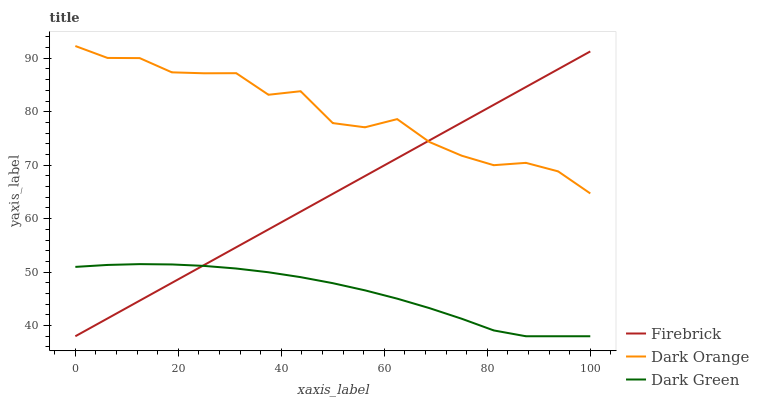Does Dark Green have the minimum area under the curve?
Answer yes or no. Yes. Does Dark Orange have the maximum area under the curve?
Answer yes or no. Yes. Does Firebrick have the minimum area under the curve?
Answer yes or no. No. Does Firebrick have the maximum area under the curve?
Answer yes or no. No. Is Firebrick the smoothest?
Answer yes or no. Yes. Is Dark Orange the roughest?
Answer yes or no. Yes. Is Dark Green the smoothest?
Answer yes or no. No. Is Dark Green the roughest?
Answer yes or no. No. Does Firebrick have the lowest value?
Answer yes or no. Yes. Does Dark Orange have the highest value?
Answer yes or no. Yes. Does Firebrick have the highest value?
Answer yes or no. No. Is Dark Green less than Dark Orange?
Answer yes or no. Yes. Is Dark Orange greater than Dark Green?
Answer yes or no. Yes. Does Dark Orange intersect Firebrick?
Answer yes or no. Yes. Is Dark Orange less than Firebrick?
Answer yes or no. No. Is Dark Orange greater than Firebrick?
Answer yes or no. No. Does Dark Green intersect Dark Orange?
Answer yes or no. No. 